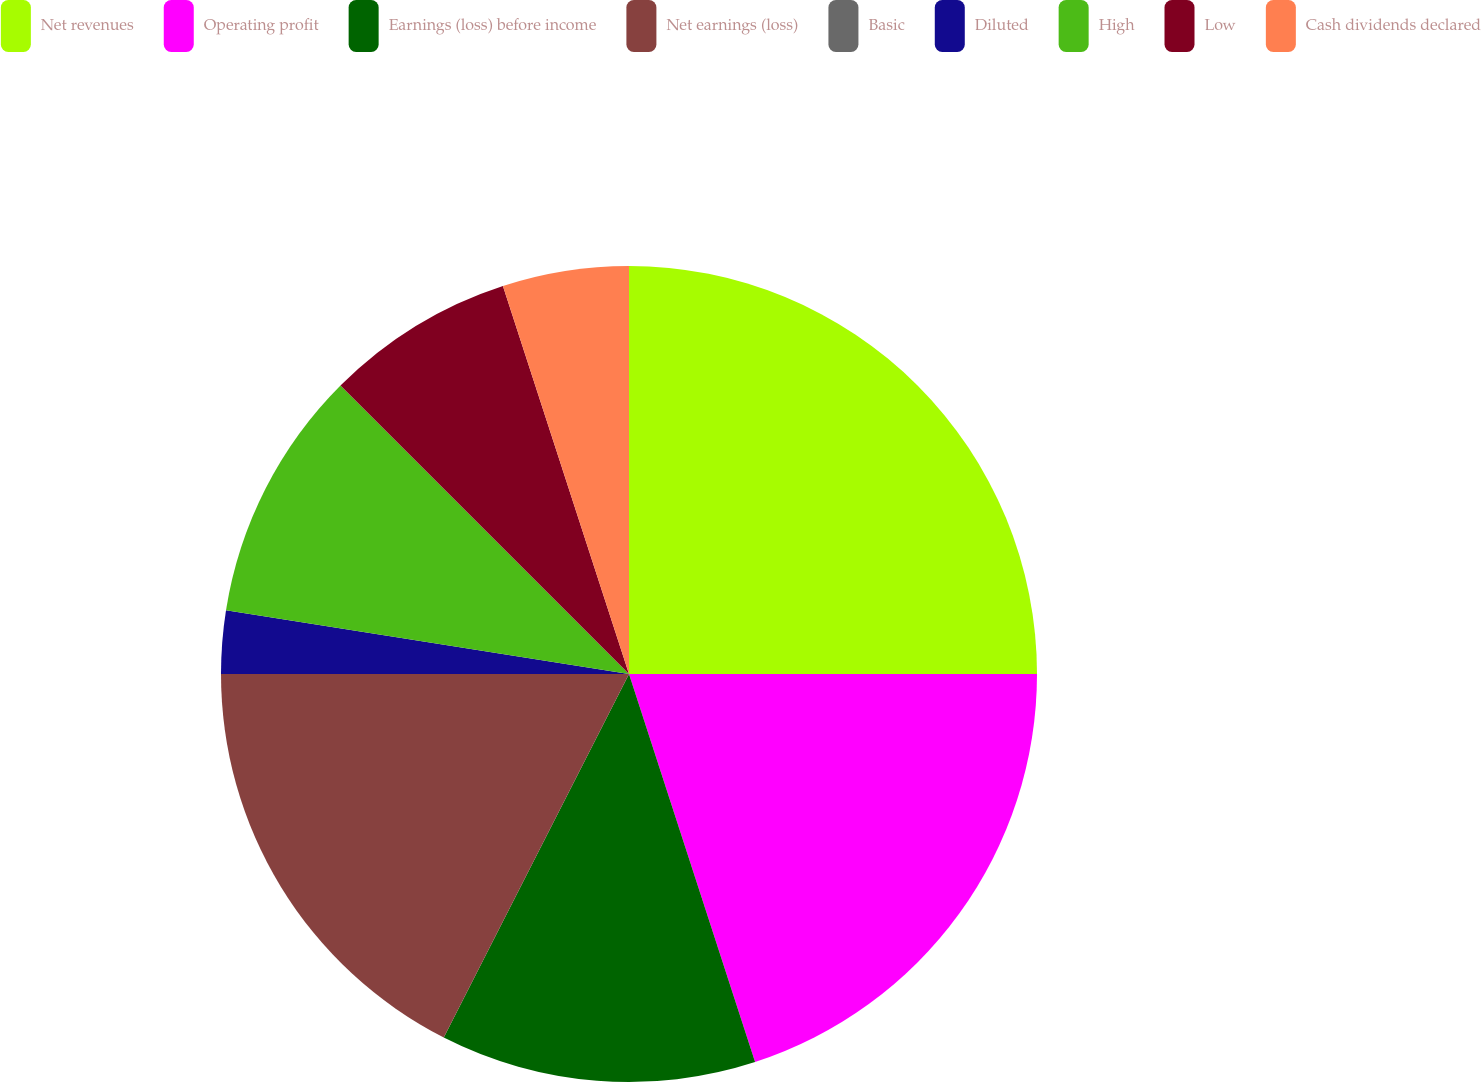<chart> <loc_0><loc_0><loc_500><loc_500><pie_chart><fcel>Net revenues<fcel>Operating profit<fcel>Earnings (loss) before income<fcel>Net earnings (loss)<fcel>Basic<fcel>Diluted<fcel>High<fcel>Low<fcel>Cash dividends declared<nl><fcel>25.0%<fcel>20.0%<fcel>12.5%<fcel>17.5%<fcel>0.0%<fcel>2.5%<fcel>10.0%<fcel>7.5%<fcel>5.0%<nl></chart> 